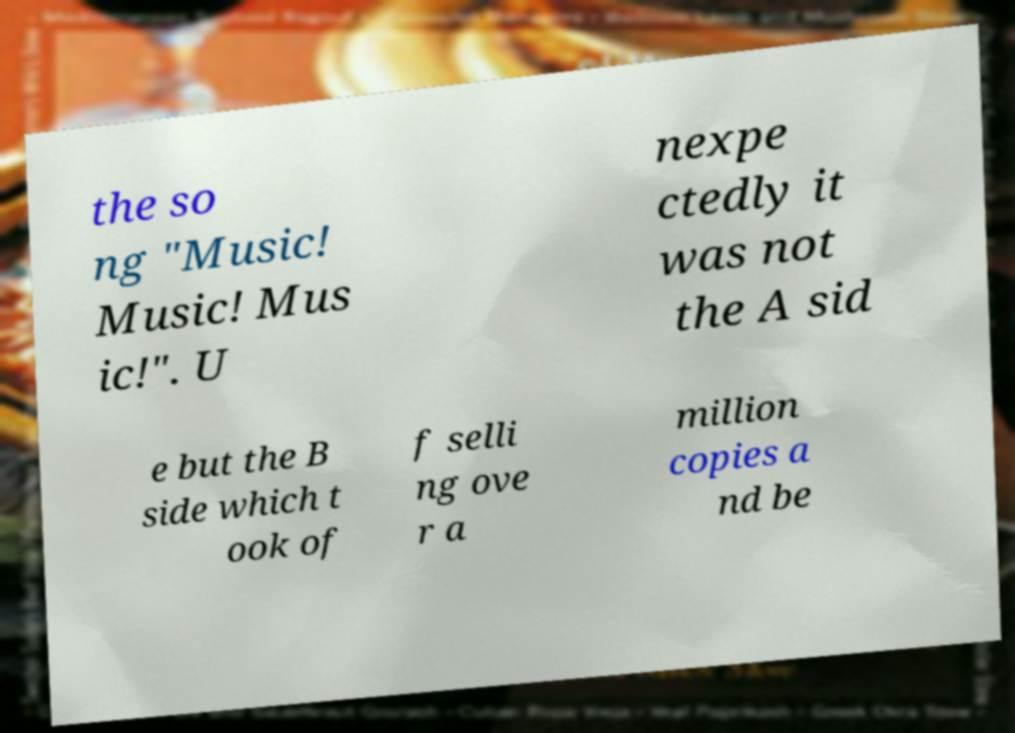Can you read and provide the text displayed in the image?This photo seems to have some interesting text. Can you extract and type it out for me? the so ng "Music! Music! Mus ic!". U nexpe ctedly it was not the A sid e but the B side which t ook of f selli ng ove r a million copies a nd be 